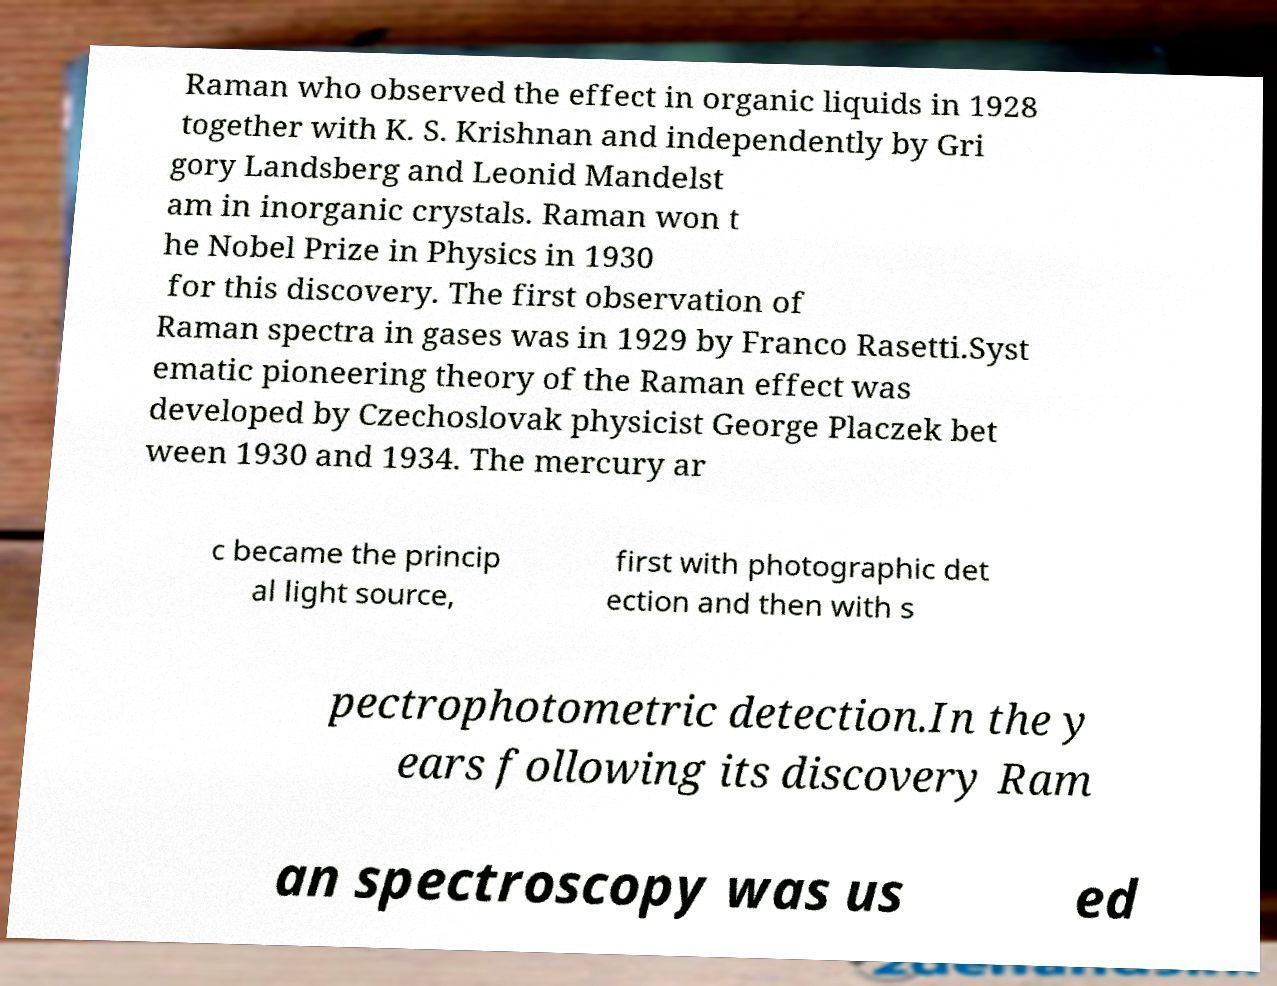Could you extract and type out the text from this image? Raman who observed the effect in organic liquids in 1928 together with K. S. Krishnan and independently by Gri gory Landsberg and Leonid Mandelst am in inorganic crystals. Raman won t he Nobel Prize in Physics in 1930 for this discovery. The first observation of Raman spectra in gases was in 1929 by Franco Rasetti.Syst ematic pioneering theory of the Raman effect was developed by Czechoslovak physicist George Placzek bet ween 1930 and 1934. The mercury ar c became the princip al light source, first with photographic det ection and then with s pectrophotometric detection.In the y ears following its discovery Ram an spectroscopy was us ed 